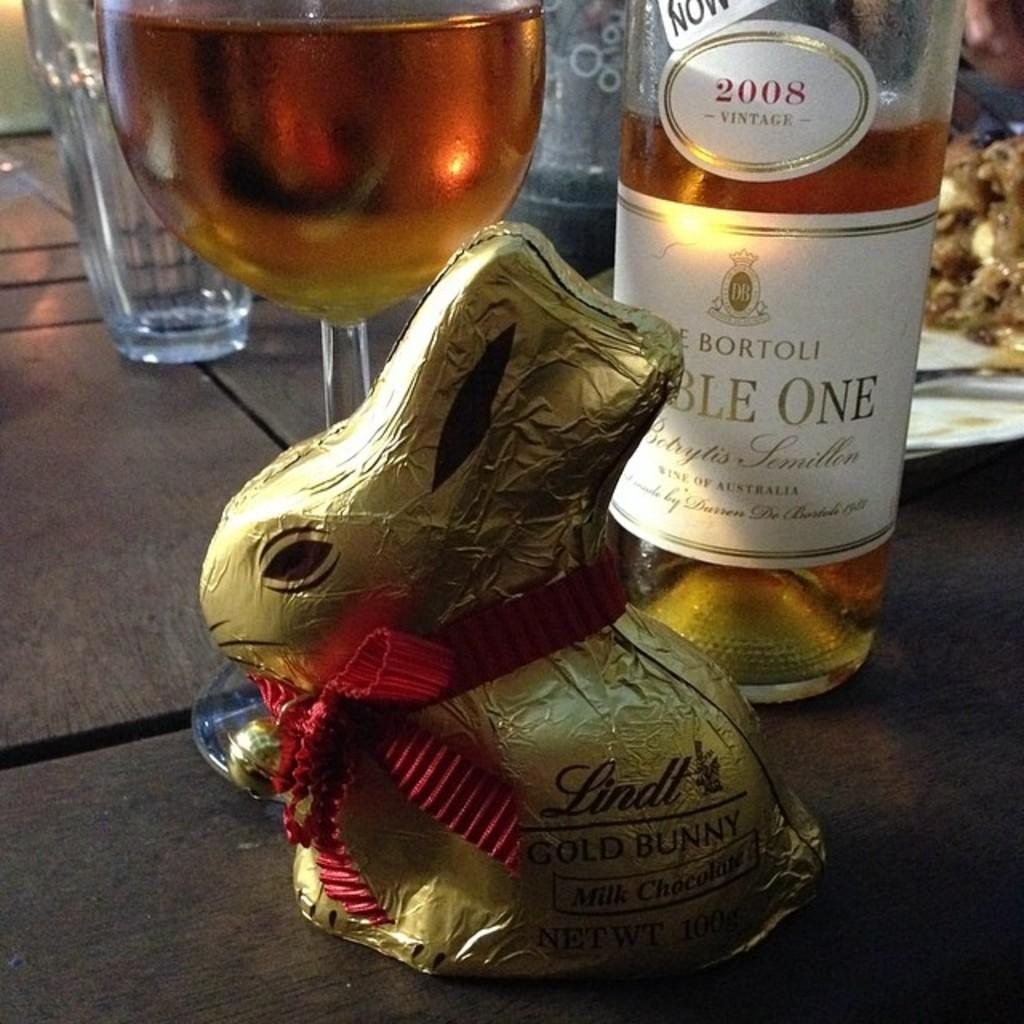What piece of furniture is present in the image? There is a table in the image. What is placed on the table? The table has a wine bottle, a glass of wine, and a chocolate on it. What type of beverage is in the glass on the table? There is a glass of wine on the table. What else can be found on the table besides the wine bottle and glass? There is a chocolate on the table, and there are also other eatables present. What type of bushes can be seen in the aftermath of the kick in the image? There is no kick or bushes present in the image; it features a table with a wine bottle, glass of wine, chocolate, and other eatables. 